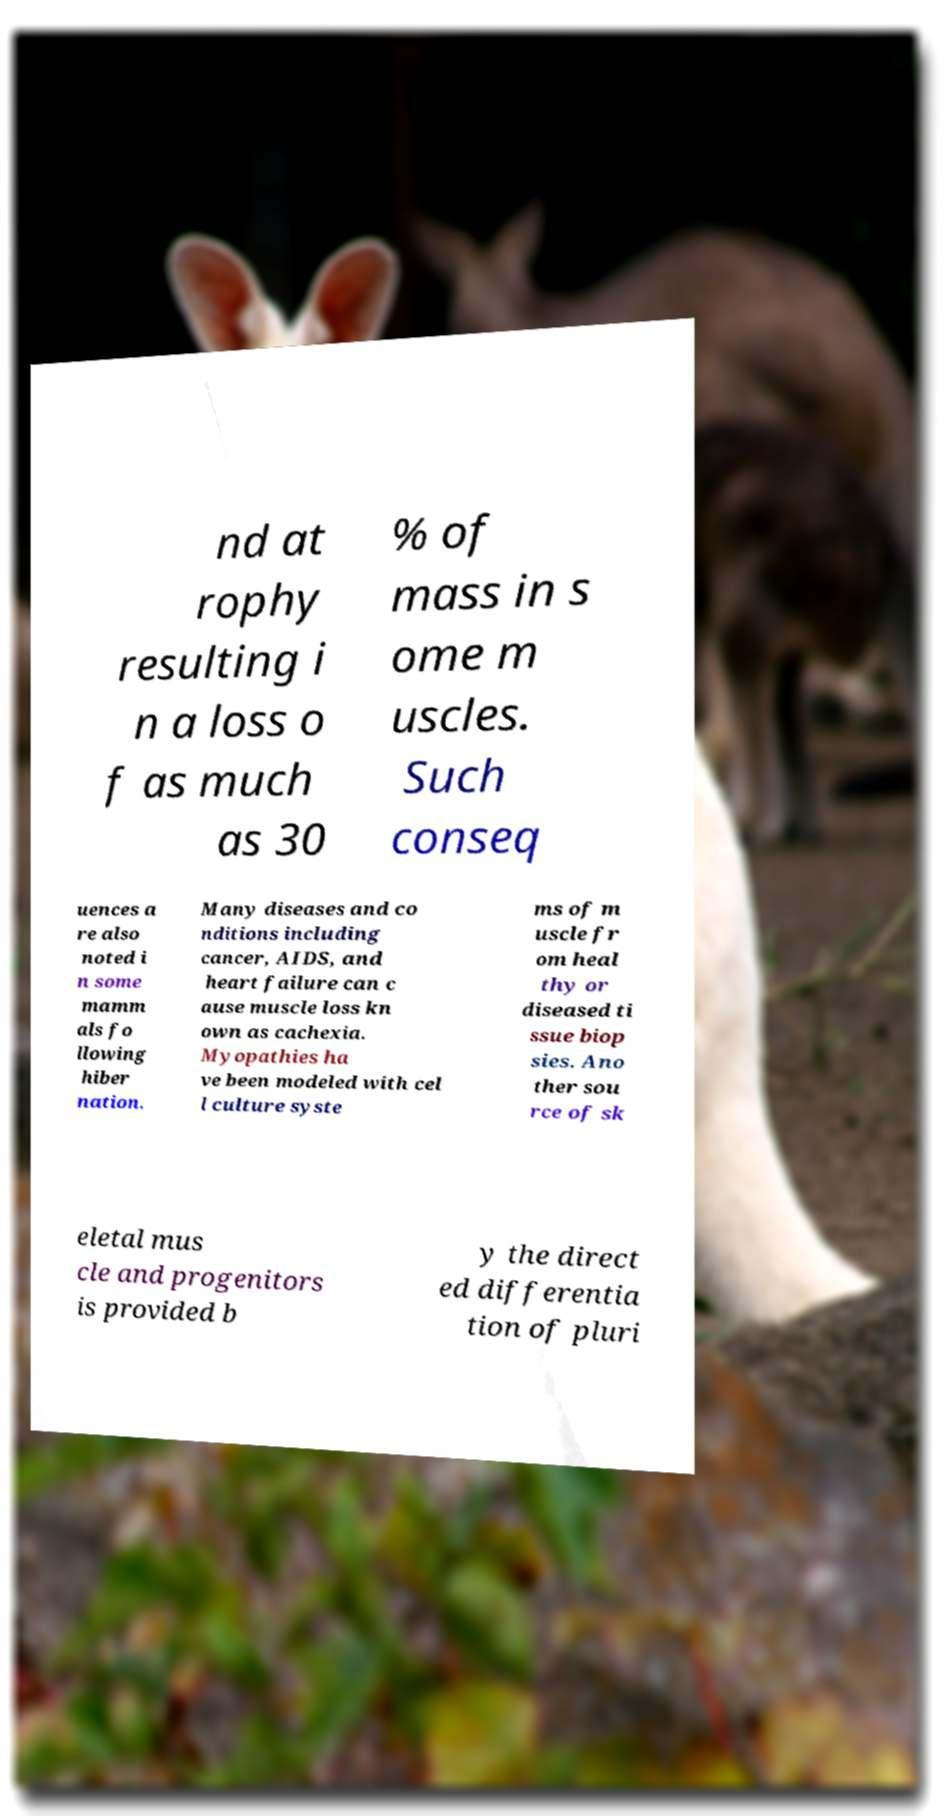For documentation purposes, I need the text within this image transcribed. Could you provide that? nd at rophy resulting i n a loss o f as much as 30 % of mass in s ome m uscles. Such conseq uences a re also noted i n some mamm als fo llowing hiber nation. Many diseases and co nditions including cancer, AIDS, and heart failure can c ause muscle loss kn own as cachexia. Myopathies ha ve been modeled with cel l culture syste ms of m uscle fr om heal thy or diseased ti ssue biop sies. Ano ther sou rce of sk eletal mus cle and progenitors is provided b y the direct ed differentia tion of pluri 